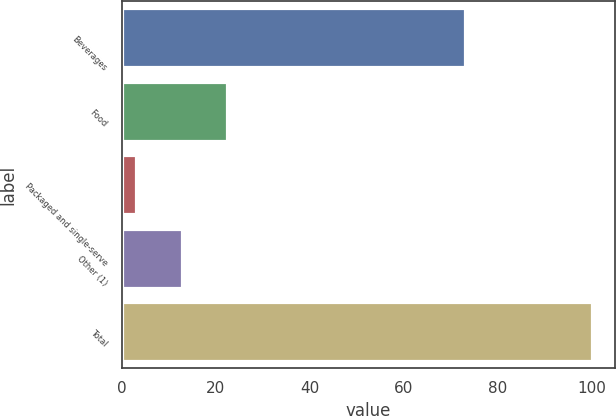Convert chart. <chart><loc_0><loc_0><loc_500><loc_500><bar_chart><fcel>Beverages<fcel>Food<fcel>Packaged and single-serve<fcel>Other (1)<fcel>Total<nl><fcel>73<fcel>22.4<fcel>3<fcel>12.7<fcel>100<nl></chart> 